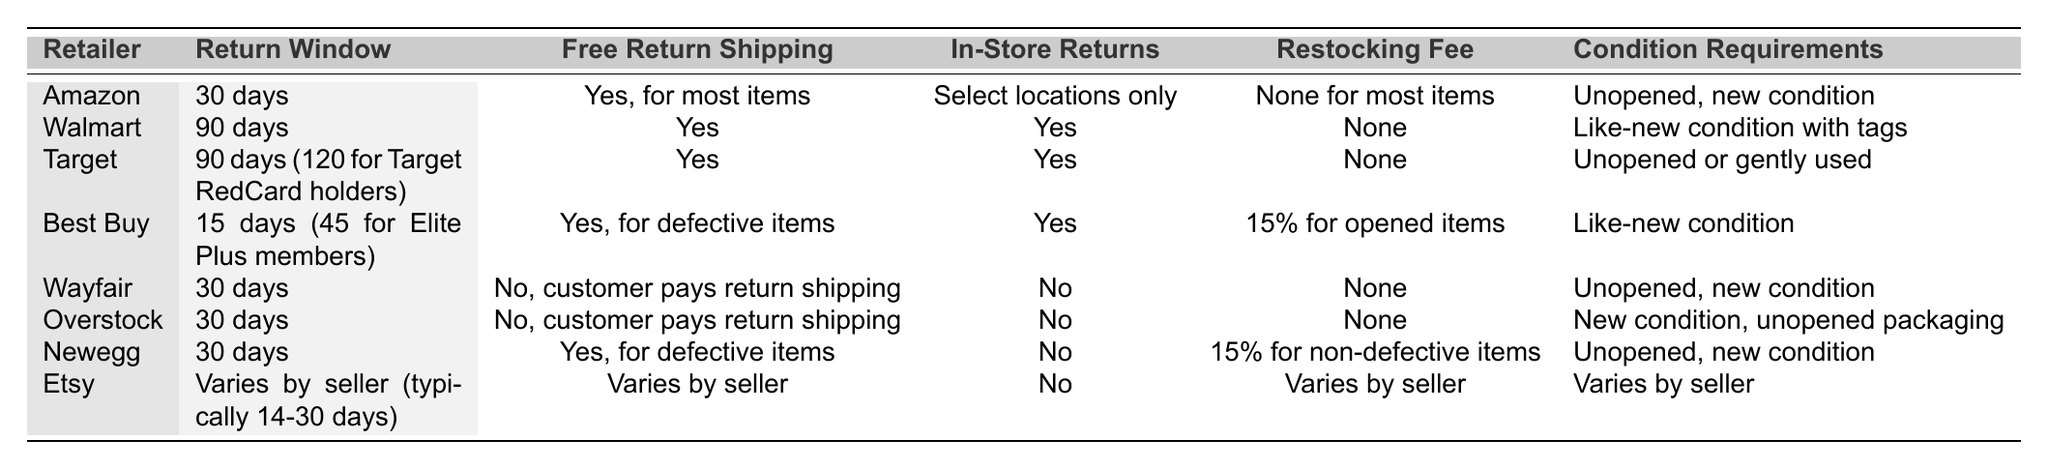What is the return window for Walmart? The table lists Walmart's return window as 90 days.
Answer: 90 days Does Amazon charge a restocking fee for most items? According to the table, Amazon has no restocking fee for most items.
Answer: No What is the longest return window indicated in the table? Both Walmart and Target offer a return window of 90 days, which is the longest.
Answer: 90 days Is free return shipping available for Newegg's defective items? The table states that Newegg offers free return shipping for defective items.
Answer: Yes Which retailers allow in-store returns? The table shows that Walmart, Target, and Best Buy allow in-store returns.
Answer: Walmart, Target, Best Buy What is the condition requirement for items returned to Wayfair? The table specifies that items must be unopened and in new condition when returned to Wayfair.
Answer: Unopened, new condition How does the return window for Best Buy compare to that of Target? Best Buy has a return window of 15 days (or 45 for Elite Plus members), which is shorter than Target's 90 days or 120 for RedCard holders.
Answer: Best Buy is shorter Which retailer has the most lenient return policy regarding the condition of items? Target allows returns of gently used items, making it more lenient than others, which typically require unopened or new conditions.
Answer: Target If a customer needs to return a defective item to Best Buy, is there any restocking fee? The table shows that Best Buy charges a 15% restocking fee for opened items, but it does not specify for defective items; thus, they may not charge it for defective returns.
Answer: Not specified, but likely no fee for defective items Which retailers require customers to pay for return shipping? Wayfair and Overstock both require customers to pay for return shipping, as indicated in the table.
Answer: Wayfair, Overstock 